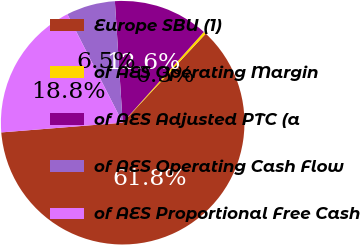Convert chart to OTSL. <chart><loc_0><loc_0><loc_500><loc_500><pie_chart><fcel>Europe SBU (1)<fcel>of AES Operating Margin<fcel>of AES Adjusted PTC (a<fcel>of AES Operating Cash Flow<fcel>of AES Proportional Free Cash<nl><fcel>61.78%<fcel>0.34%<fcel>12.63%<fcel>6.48%<fcel>18.77%<nl></chart> 